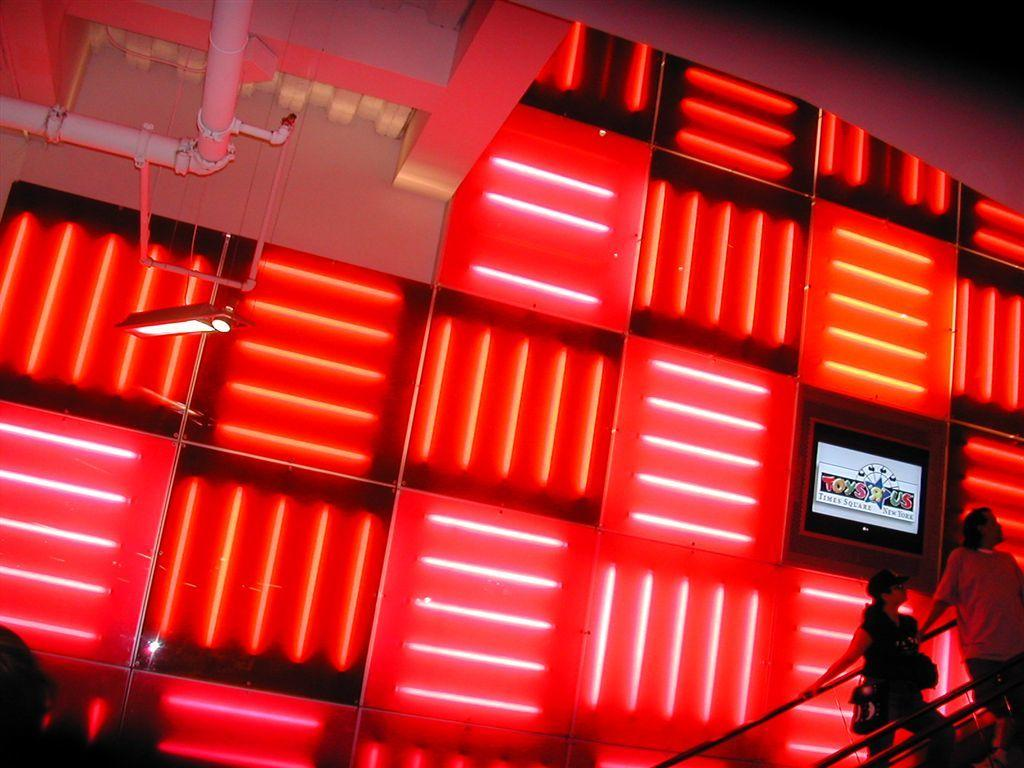What can be seen on the right side of the image? There is a hand railing for two persons on the right side of the image. What elements are present on the left side of the image? There are pipes, a ceiling, and a light on the left side of the image. What color is the light in the image? There is a red color light in the image. Is there any additional decoration or information in the image? Yes, there is a poster in the image. Can you see any ants crawling on the stone floor in the image? There is no mention of a stone floor or ants in the image. 